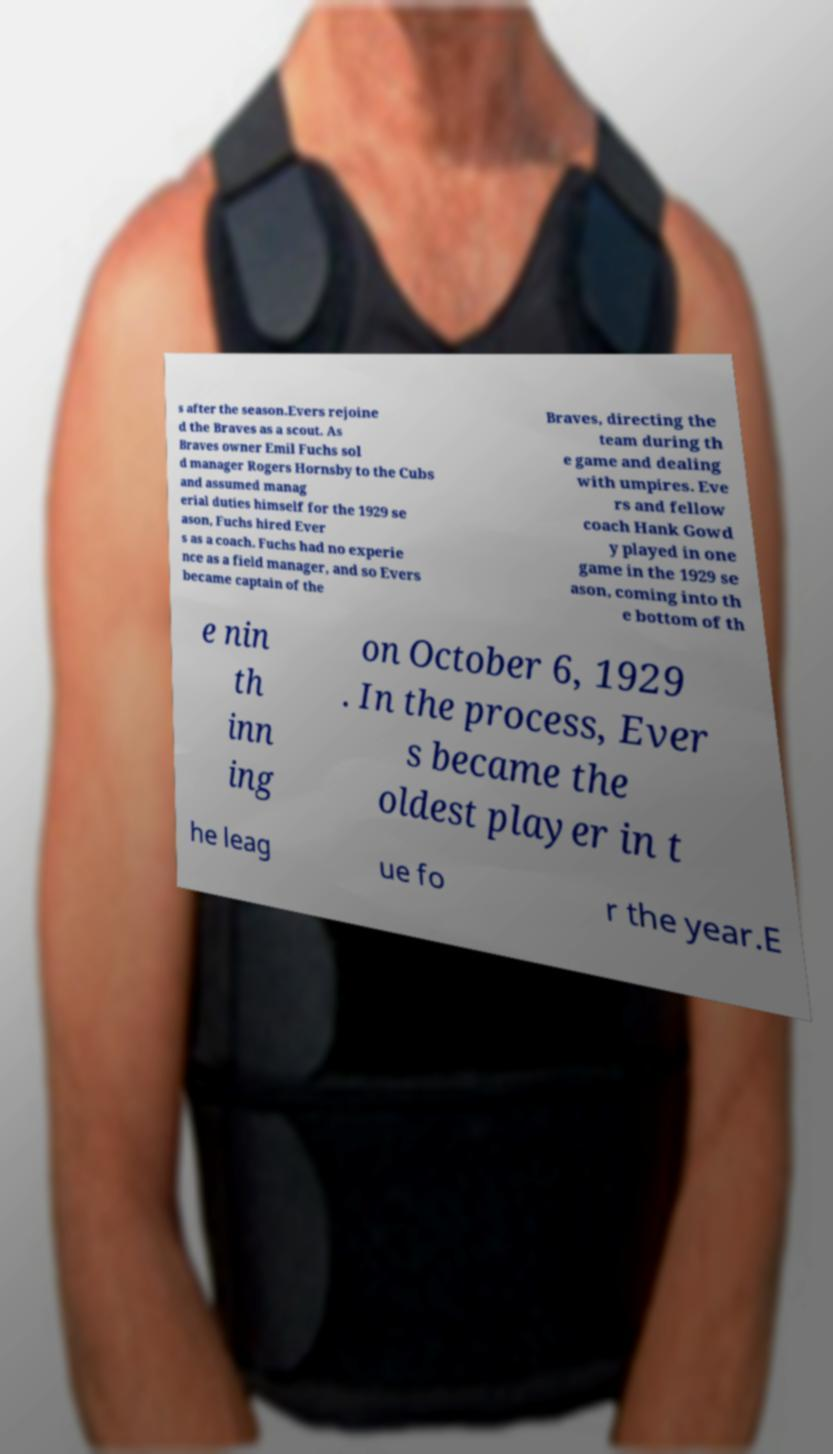Please identify and transcribe the text found in this image. s after the season.Evers rejoine d the Braves as a scout. As Braves owner Emil Fuchs sol d manager Rogers Hornsby to the Cubs and assumed manag erial duties himself for the 1929 se ason, Fuchs hired Ever s as a coach. Fuchs had no experie nce as a field manager, and so Evers became captain of the Braves, directing the team during th e game and dealing with umpires. Eve rs and fellow coach Hank Gowd y played in one game in the 1929 se ason, coming into th e bottom of th e nin th inn ing on October 6, 1929 . In the process, Ever s became the oldest player in t he leag ue fo r the year.E 